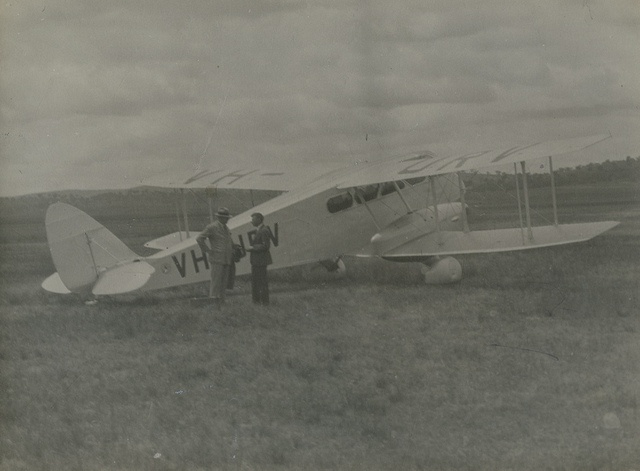Describe the objects in this image and their specific colors. I can see airplane in darkgray, gray, and black tones, people in darkgray, gray, and black tones, people in darkgray, black, and gray tones, suitcase in black, gray, and darkgray tones, and tie in darkgray, gray, and black tones in this image. 